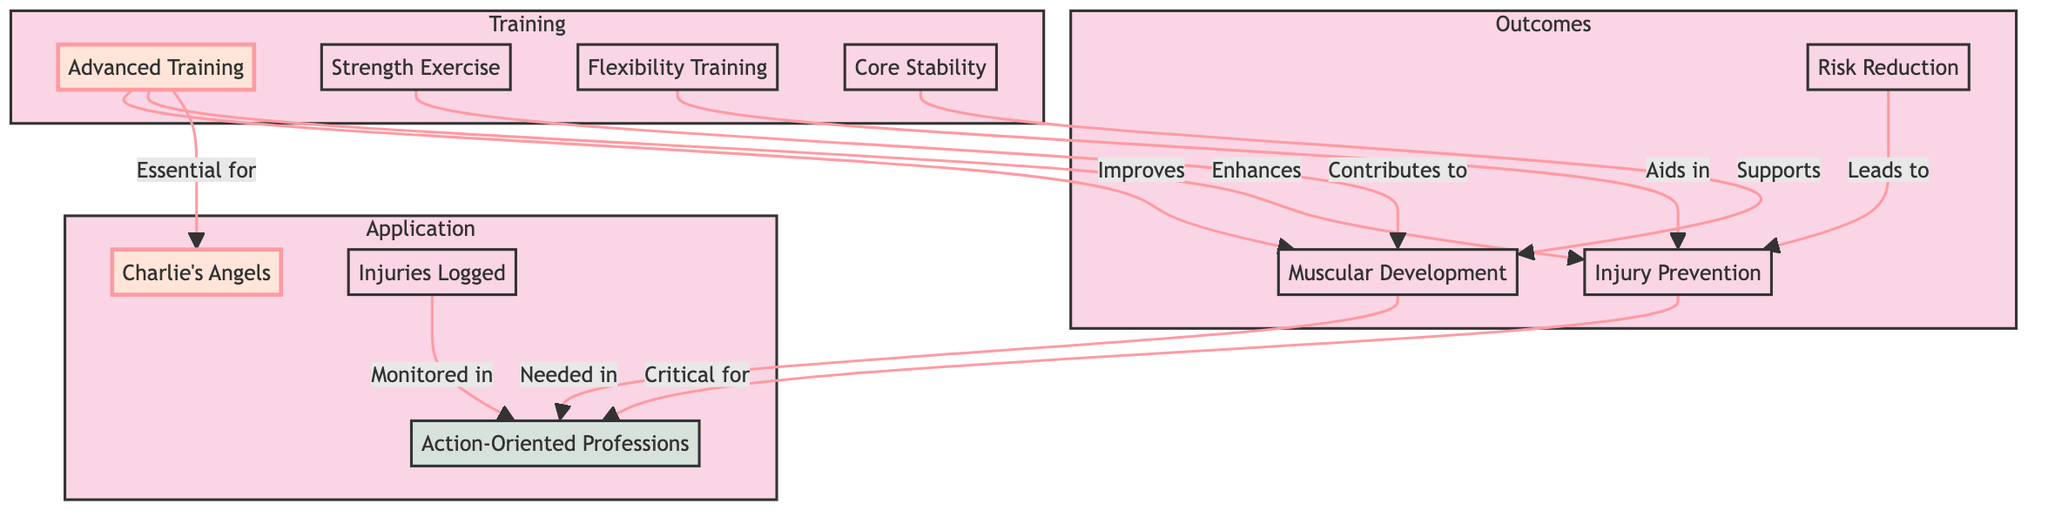What is the primary focus of the advanced training? The advanced training is primarily focused on improving muscular development and enhancing injury prevention, as indicated by the arrows pointing from the "Advanced Training" node to both "Muscular Development" and "Injury Prevention."
Answer: Improving muscular development and enhancing injury prevention How many nodes are there in the diagram? To determine the number of nodes, we can count each distinct labeled item in the diagram. There are 9 key nodes: Advanced Training, Muscular Development, Injury Prevention, Action-Oriented Professions, Charlie's Angels, Strength Exercise, Flexibility Training, Core Stability, and Injuries Logged.
Answer: 9 What is one contribution of strength exercise? Strength exercise contributes to muscular development as shown by the connection from "Strength Exercise" to "Muscular Development."
Answer: Contributes to muscular development Which node is deemed essential for Charlie's Angels? The diagram states that advanced training is essential for Charlie's Angels, as shown by the direct connection from "Advanced Training" to "Charlie's Angels."
Answer: Advanced Training What leads to injury prevention according to the diagram? Risk reduction is indicated in the diagram as leading to injury prevention based on the directed edge from "Risk Reduction" to "Injury Prevention."
Answer: Risk Reduction What type of training aids in injury prevention? Flexibility training is identified in the diagram as aiding in injury prevention through the connection from "Flexibility Training" to "Injury Prevention."
Answer: Flexibility Training How are injuries logged in the context of action-oriented professions? Injuries are logged as monitored in action-oriented professions, which is evident from the connection between "Injuries Logged" and "Action-Oriented Professions."
Answer: Monitored What supports muscular development according to the diagram? Core stability supports muscular development, as shown by the arrow pointing from "Core Stability" to "Muscular Development."
Answer: Core Stability Which profession is associated with both muscular development and injury prevention? Action-oriented professions are associated with both muscular development and injury prevention, as they are directly influenced by both these factors in the diagram.
Answer: Action-Oriented Professions 